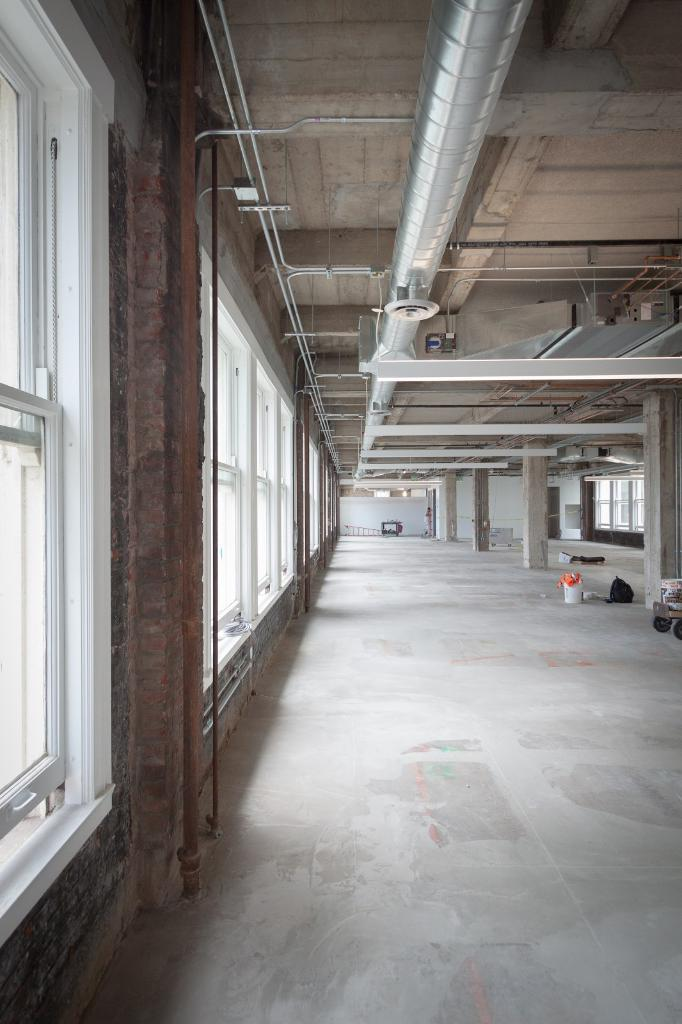What type of location is depicted in the image? The image shows an inside view of a building. What can be seen attached to the ceiling in the image? There is a pipe attached to the ceiling in the image. What architectural features are present in the image? There are pillars in the image. What is on the floor in the image? There are objects on the floor in the image. What allows natural light to enter the building in the image? There are windows in the walls that allow natural light to enter the building. How much money is being exchanged between the pillars in the image? There is no money exchange depicted in the image; it only shows the pillars and other architectural features. What type of lamp is hanging from the ceiling in the image? There is no lamp present in the image; only a pipe is attached to the ceiling. 